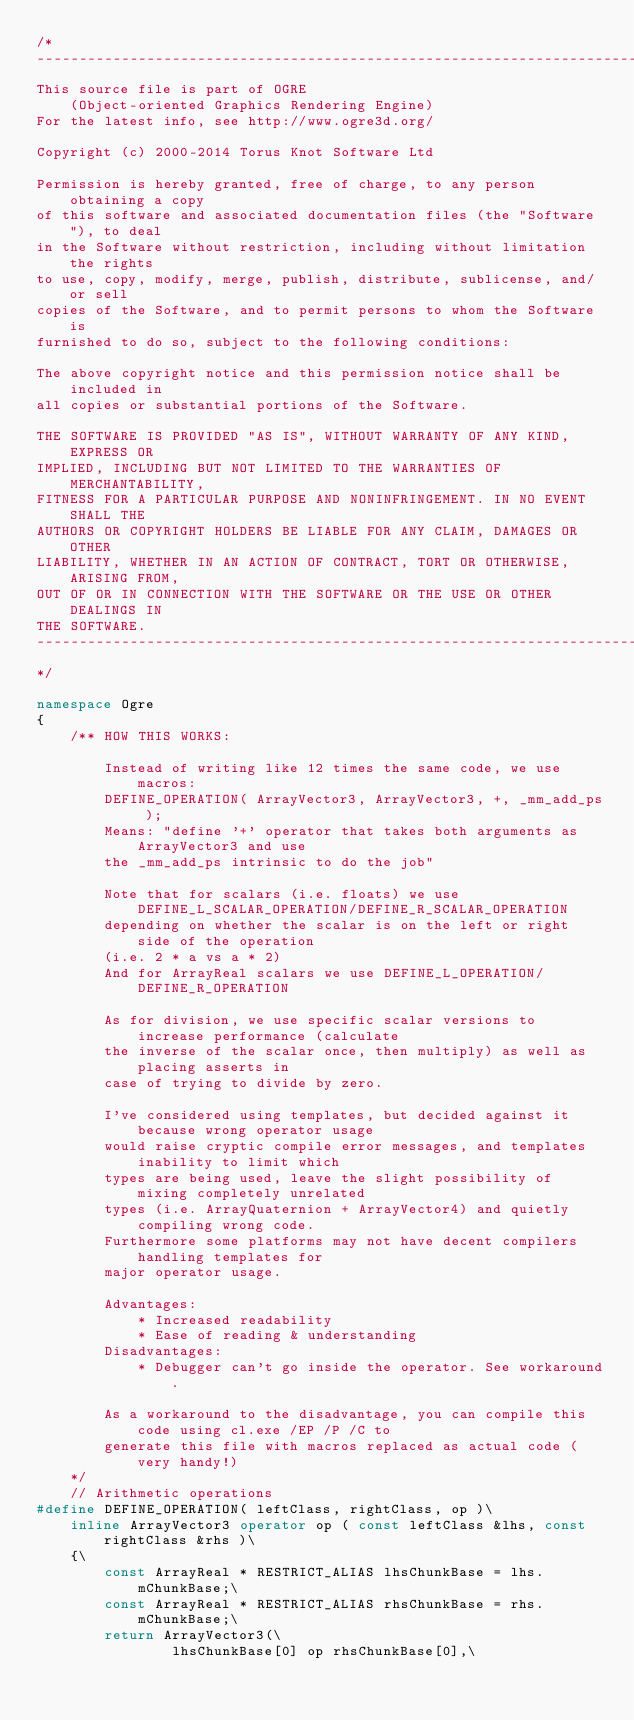Convert code to text. <code><loc_0><loc_0><loc_500><loc_500><_C++_>/*
-----------------------------------------------------------------------------
This source file is part of OGRE
    (Object-oriented Graphics Rendering Engine)
For the latest info, see http://www.ogre3d.org/

Copyright (c) 2000-2014 Torus Knot Software Ltd

Permission is hereby granted, free of charge, to any person obtaining a copy
of this software and associated documentation files (the "Software"), to deal
in the Software without restriction, including without limitation the rights
to use, copy, modify, merge, publish, distribute, sublicense, and/or sell
copies of the Software, and to permit persons to whom the Software is
furnished to do so, subject to the following conditions:

The above copyright notice and this permission notice shall be included in
all copies or substantial portions of the Software.

THE SOFTWARE IS PROVIDED "AS IS", WITHOUT WARRANTY OF ANY KIND, EXPRESS OR
IMPLIED, INCLUDING BUT NOT LIMITED TO THE WARRANTIES OF MERCHANTABILITY,
FITNESS FOR A PARTICULAR PURPOSE AND NONINFRINGEMENT. IN NO EVENT SHALL THE
AUTHORS OR COPYRIGHT HOLDERS BE LIABLE FOR ANY CLAIM, DAMAGES OR OTHER
LIABILITY, WHETHER IN AN ACTION OF CONTRACT, TORT OR OTHERWISE, ARISING FROM,
OUT OF OR IN CONNECTION WITH THE SOFTWARE OR THE USE OR OTHER DEALINGS IN
THE SOFTWARE.
-----------------------------------------------------------------------------
*/

namespace Ogre
{
    /** HOW THIS WORKS:

        Instead of writing like 12 times the same code, we use macros:
        DEFINE_OPERATION( ArrayVector3, ArrayVector3, +, _mm_add_ps );
        Means: "define '+' operator that takes both arguments as ArrayVector3 and use
        the _mm_add_ps intrinsic to do the job"

        Note that for scalars (i.e. floats) we use DEFINE_L_SCALAR_OPERATION/DEFINE_R_SCALAR_OPERATION
        depending on whether the scalar is on the left or right side of the operation
        (i.e. 2 * a vs a * 2)
        And for ArrayReal scalars we use DEFINE_L_OPERATION/DEFINE_R_OPERATION

        As for division, we use specific scalar versions to increase performance (calculate
        the inverse of the scalar once, then multiply) as well as placing asserts in
        case of trying to divide by zero.

        I've considered using templates, but decided against it because wrong operator usage
        would raise cryptic compile error messages, and templates inability to limit which
        types are being used, leave the slight possibility of mixing completely unrelated
        types (i.e. ArrayQuaternion + ArrayVector4) and quietly compiling wrong code.
        Furthermore some platforms may not have decent compilers handling templates for
        major operator usage.

        Advantages:
            * Increased readability
            * Ease of reading & understanding
        Disadvantages:
            * Debugger can't go inside the operator. See workaround.

        As a workaround to the disadvantage, you can compile this code using cl.exe /EP /P /C to
        generate this file with macros replaced as actual code (very handy!)
    */
    // Arithmetic operations
#define DEFINE_OPERATION( leftClass, rightClass, op )\
    inline ArrayVector3 operator op ( const leftClass &lhs, const rightClass &rhs )\
    {\
        const ArrayReal * RESTRICT_ALIAS lhsChunkBase = lhs.mChunkBase;\
        const ArrayReal * RESTRICT_ALIAS rhsChunkBase = rhs.mChunkBase;\
        return ArrayVector3(\
                lhsChunkBase[0] op rhsChunkBase[0],\</code> 